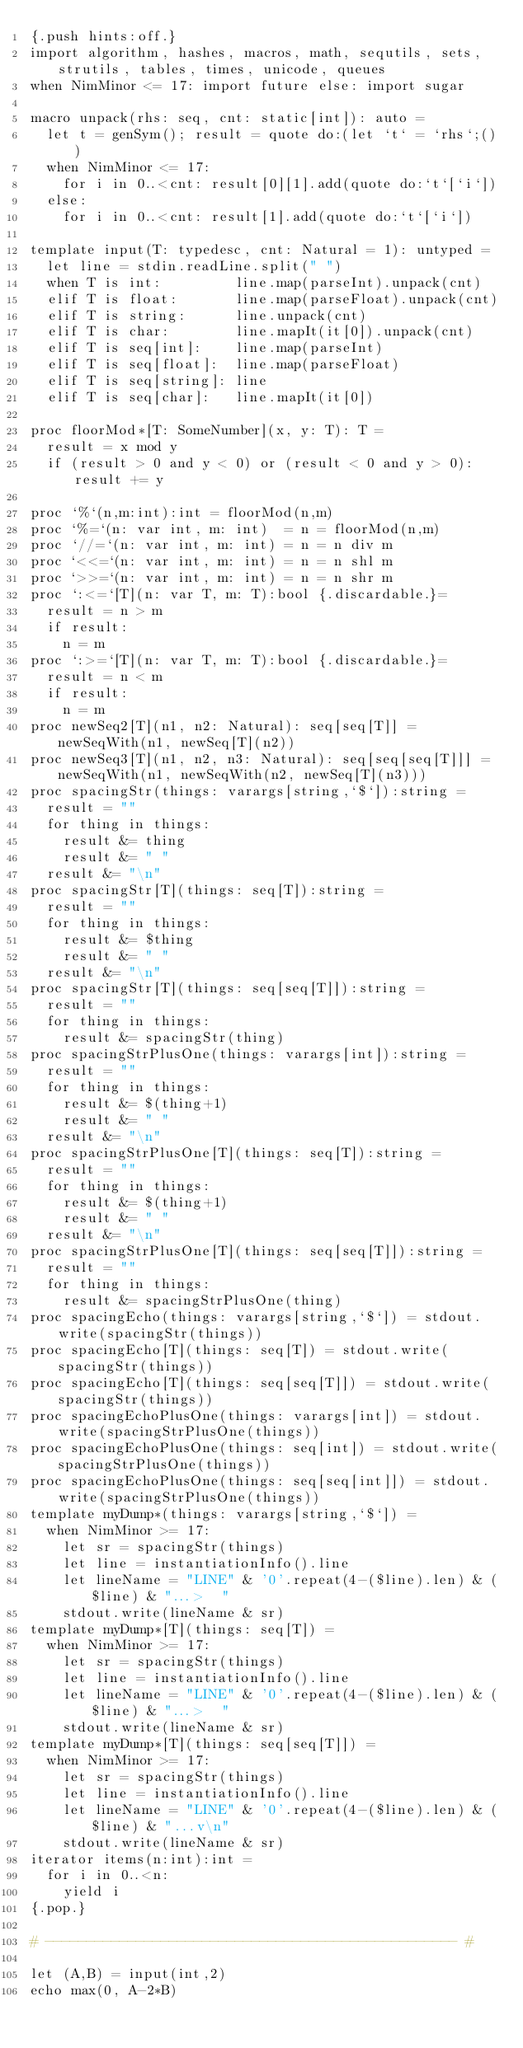<code> <loc_0><loc_0><loc_500><loc_500><_Nim_>{.push hints:off.}
import algorithm, hashes, macros, math, sequtils, sets, strutils, tables, times, unicode, queues
when NimMinor <= 17: import future else: import sugar

macro unpack(rhs: seq, cnt: static[int]): auto =
  let t = genSym(); result = quote do:(let `t` = `rhs`;())
  when NimMinor <= 17:
    for i in 0..<cnt: result[0][1].add(quote do:`t`[`i`])
  else:
    for i in 0..<cnt: result[1].add(quote do:`t`[`i`])
 
template input(T: typedesc, cnt: Natural = 1): untyped =
  let line = stdin.readLine.split(" ")
  when T is int:         line.map(parseInt).unpack(cnt)
  elif T is float:       line.map(parseFloat).unpack(cnt)
  elif T is string:      line.unpack(cnt)
  elif T is char:        line.mapIt(it[0]).unpack(cnt)
  elif T is seq[int]:    line.map(parseInt)
  elif T is seq[float]:  line.map(parseFloat)
  elif T is seq[string]: line
  elif T is seq[char]:   line.mapIt(it[0])

proc floorMod*[T: SomeNumber](x, y: T): T =
  result = x mod y
  if (result > 0 and y < 0) or (result < 0 and y > 0): result += y

proc `%`(n,m:int):int = floorMod(n,m)
proc `%=`(n: var int, m: int)  = n = floorMod(n,m)
proc `//=`(n: var int, m: int) = n = n div m
proc `<<=`(n: var int, m: int) = n = n shl m
proc `>>=`(n: var int, m: int) = n = n shr m
proc `:<=`[T](n: var T, m: T):bool {.discardable.}=
  result = n > m
  if result:
    n = m
proc `:>=`[T](n: var T, m: T):bool {.discardable.}=
  result = n < m
  if result:
    n = m
proc newSeq2[T](n1, n2: Natural): seq[seq[T]] = newSeqWith(n1, newSeq[T](n2))
proc newSeq3[T](n1, n2, n3: Natural): seq[seq[seq[T]]] = newSeqWith(n1, newSeqWith(n2, newSeq[T](n3)))
proc spacingStr(things: varargs[string,`$`]):string =
  result = ""
  for thing in things:
    result &= thing
    result &= " "
  result &= "\n"
proc spacingStr[T](things: seq[T]):string =
  result = ""
  for thing in things:
    result &= $thing
    result &= " "
  result &= "\n"
proc spacingStr[T](things: seq[seq[T]]):string =
  result = ""
  for thing in things:
    result &= spacingStr(thing)
proc spacingStrPlusOne(things: varargs[int]):string =
  result = ""
  for thing in things:
    result &= $(thing+1)
    result &= " "
  result &= "\n"
proc spacingStrPlusOne[T](things: seq[T]):string =
  result = ""
  for thing in things:
    result &= $(thing+1)
    result &= " "
  result &= "\n"
proc spacingStrPlusOne[T](things: seq[seq[T]]):string =
  result = ""
  for thing in things:
    result &= spacingStrPlusOne(thing)
proc spacingEcho(things: varargs[string,`$`]) = stdout.write(spacingStr(things))
proc spacingEcho[T](things: seq[T]) = stdout.write(spacingStr(things))
proc spacingEcho[T](things: seq[seq[T]]) = stdout.write(spacingStr(things))
proc spacingEchoPlusOne(things: varargs[int]) = stdout.write(spacingStrPlusOne(things))
proc spacingEchoPlusOne(things: seq[int]) = stdout.write(spacingStrPlusOne(things))
proc spacingEchoPlusOne(things: seq[seq[int]]) = stdout.write(spacingStrPlusOne(things))
template myDump*(things: varargs[string,`$`]) =
  when NimMinor >= 17:
    let sr = spacingStr(things)
    let line = instantiationInfo().line
    let lineName = "LINE" & '0'.repeat(4-($line).len) & ($line) & "...>  "
    stdout.write(lineName & sr)
template myDump*[T](things: seq[T]) =
  when NimMinor >= 17:
    let sr = spacingStr(things)
    let line = instantiationInfo().line
    let lineName = "LINE" & '0'.repeat(4-($line).len) & ($line) & "...>  "
    stdout.write(lineName & sr)
template myDump*[T](things: seq[seq[T]]) =
  when NimMinor >= 17:
    let sr = spacingStr(things)
    let line = instantiationInfo().line
    let lineName = "LINE" & '0'.repeat(4-($line).len) & ($line) & "...v\n"
    stdout.write(lineName & sr)
iterator items(n:int):int = 
  for i in 0..<n:
    yield i
{.pop.}

# -------------------------------------------------- #

let (A,B) = input(int,2)
echo max(0, A-2*B)</code> 